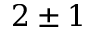<formula> <loc_0><loc_0><loc_500><loc_500>2 \pm 1</formula> 